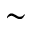Convert formula to latex. <formula><loc_0><loc_0><loc_500><loc_500>\sim</formula> 